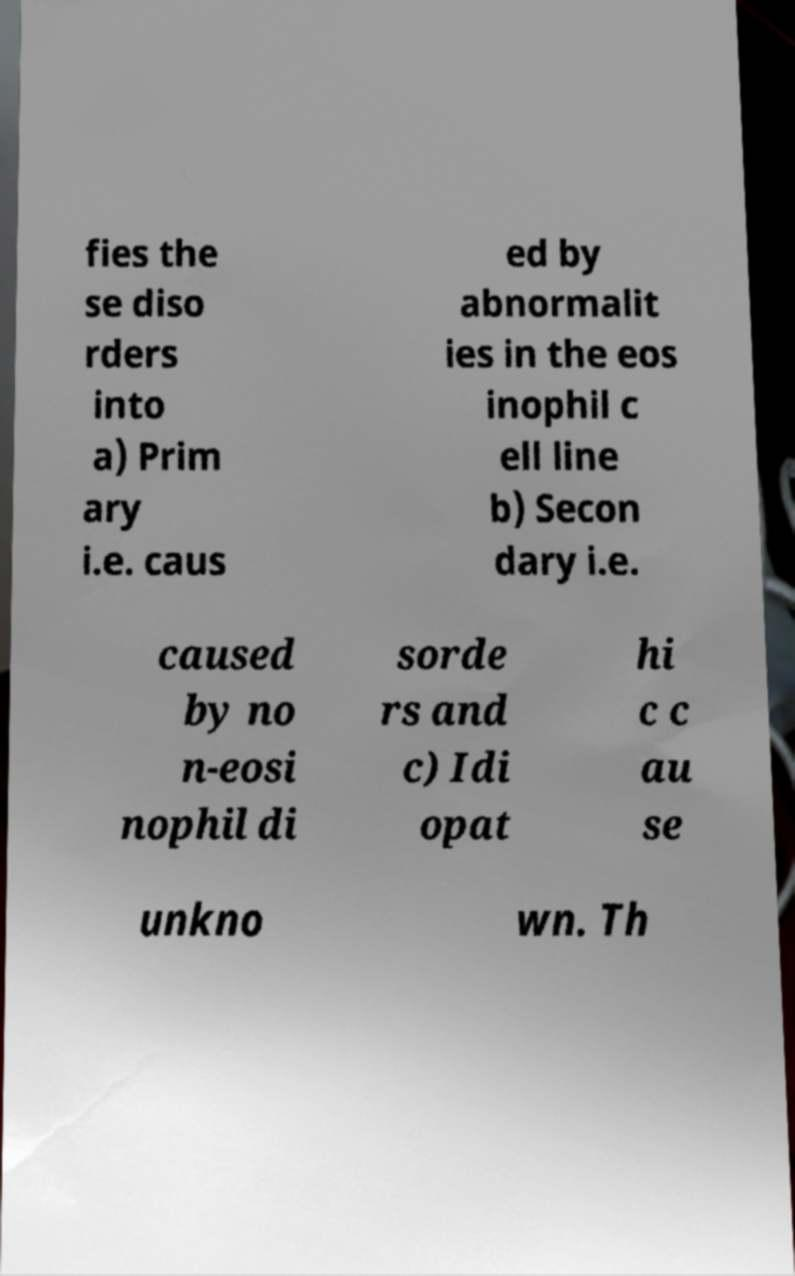Please read and relay the text visible in this image. What does it say? fies the se diso rders into a) Prim ary i.e. caus ed by abnormalit ies in the eos inophil c ell line b) Secon dary i.e. caused by no n-eosi nophil di sorde rs and c) Idi opat hi c c au se unkno wn. Th 